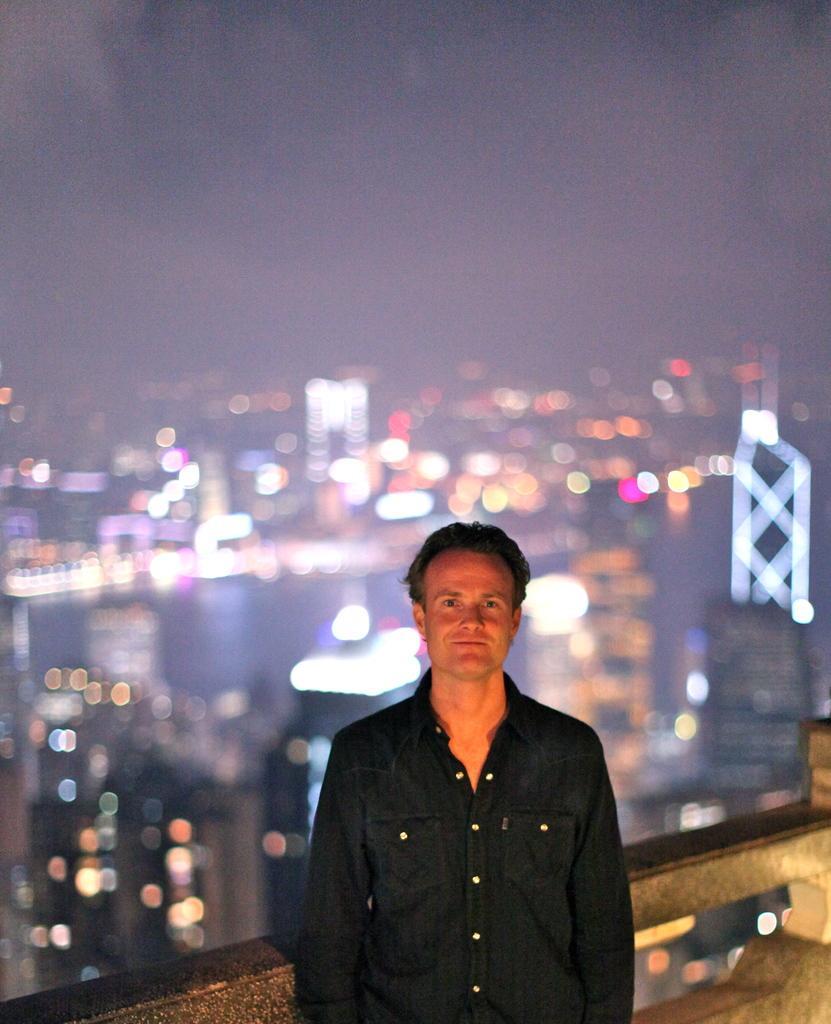Could you give a brief overview of what you see in this image? In this image, we can see a person is seeing, smiling and standing near the railing. Background there is a blur view. Here we can see few lights and sky. 